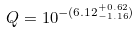<formula> <loc_0><loc_0><loc_500><loc_500>Q = 1 0 ^ { - ( 6 . 1 2 ^ { + 0 . 6 2 } _ { - 1 . 1 6 } ) }</formula> 